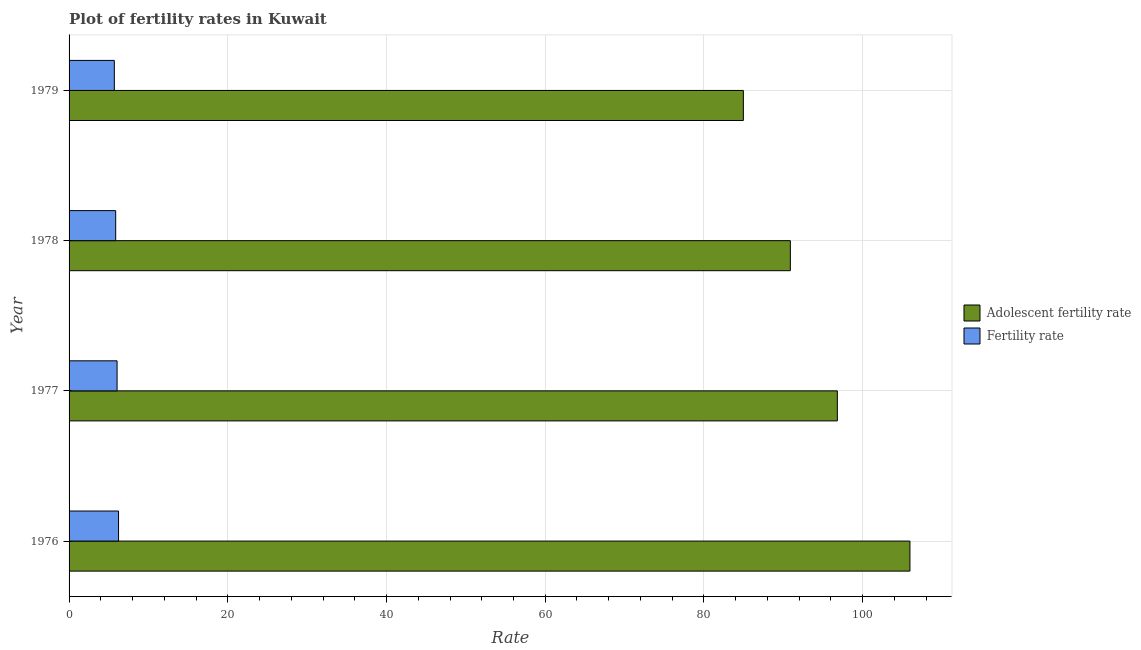How many groups of bars are there?
Make the answer very short. 4. Are the number of bars per tick equal to the number of legend labels?
Offer a very short reply. Yes. Are the number of bars on each tick of the Y-axis equal?
Offer a very short reply. Yes. How many bars are there on the 2nd tick from the bottom?
Keep it short and to the point. 2. What is the label of the 1st group of bars from the top?
Provide a succinct answer. 1979. What is the adolescent fertility rate in 1976?
Make the answer very short. 105.95. Across all years, what is the maximum fertility rate?
Your response must be concise. 6.23. Across all years, what is the minimum fertility rate?
Your response must be concise. 5.7. In which year was the fertility rate maximum?
Offer a very short reply. 1976. In which year was the adolescent fertility rate minimum?
Keep it short and to the point. 1979. What is the total adolescent fertility rate in the graph?
Keep it short and to the point. 378.61. What is the difference between the fertility rate in 1977 and that in 1978?
Offer a very short reply. 0.18. What is the difference between the fertility rate in 1976 and the adolescent fertility rate in 1978?
Offer a very short reply. -84.65. What is the average fertility rate per year?
Your answer should be very brief. 5.96. In the year 1978, what is the difference between the adolescent fertility rate and fertility rate?
Your response must be concise. 85.01. In how many years, is the adolescent fertility rate greater than 76 ?
Provide a succinct answer. 4. What is the ratio of the adolescent fertility rate in 1976 to that in 1979?
Offer a very short reply. 1.25. Is the difference between the fertility rate in 1977 and 1978 greater than the difference between the adolescent fertility rate in 1977 and 1978?
Keep it short and to the point. No. What is the difference between the highest and the second highest fertility rate?
Ensure brevity in your answer.  0.18. What is the difference between the highest and the lowest adolescent fertility rate?
Give a very brief answer. 20.99. In how many years, is the fertility rate greater than the average fertility rate taken over all years?
Your response must be concise. 2. What does the 2nd bar from the top in 1976 represents?
Provide a succinct answer. Adolescent fertility rate. What does the 1st bar from the bottom in 1976 represents?
Give a very brief answer. Adolescent fertility rate. How many bars are there?
Make the answer very short. 8. Are the values on the major ticks of X-axis written in scientific E-notation?
Your answer should be very brief. No. Does the graph contain grids?
Give a very brief answer. Yes. How many legend labels are there?
Offer a very short reply. 2. How are the legend labels stacked?
Provide a succinct answer. Vertical. What is the title of the graph?
Provide a short and direct response. Plot of fertility rates in Kuwait. Does "State government" appear as one of the legend labels in the graph?
Your answer should be very brief. No. What is the label or title of the X-axis?
Provide a succinct answer. Rate. What is the label or title of the Y-axis?
Provide a succinct answer. Year. What is the Rate of Adolescent fertility rate in 1976?
Offer a very short reply. 105.95. What is the Rate in Fertility rate in 1976?
Your answer should be compact. 6.23. What is the Rate of Adolescent fertility rate in 1977?
Provide a short and direct response. 96.81. What is the Rate in Fertility rate in 1977?
Keep it short and to the point. 6.05. What is the Rate of Adolescent fertility rate in 1978?
Offer a very short reply. 90.89. What is the Rate of Fertility rate in 1978?
Ensure brevity in your answer.  5.87. What is the Rate of Adolescent fertility rate in 1979?
Provide a succinct answer. 84.96. What is the Rate in Fertility rate in 1979?
Provide a succinct answer. 5.7. Across all years, what is the maximum Rate of Adolescent fertility rate?
Offer a very short reply. 105.95. Across all years, what is the maximum Rate in Fertility rate?
Keep it short and to the point. 6.23. Across all years, what is the minimum Rate of Adolescent fertility rate?
Your answer should be compact. 84.96. Across all years, what is the minimum Rate of Fertility rate?
Ensure brevity in your answer.  5.7. What is the total Rate in Adolescent fertility rate in the graph?
Provide a succinct answer. 378.61. What is the total Rate of Fertility rate in the graph?
Give a very brief answer. 23.86. What is the difference between the Rate in Adolescent fertility rate in 1976 and that in 1977?
Your answer should be very brief. 9.15. What is the difference between the Rate in Fertility rate in 1976 and that in 1977?
Provide a succinct answer. 0.18. What is the difference between the Rate of Adolescent fertility rate in 1976 and that in 1978?
Offer a very short reply. 15.07. What is the difference between the Rate of Fertility rate in 1976 and that in 1978?
Your answer should be very brief. 0.36. What is the difference between the Rate of Adolescent fertility rate in 1976 and that in 1979?
Provide a short and direct response. 20.99. What is the difference between the Rate in Fertility rate in 1976 and that in 1979?
Provide a succinct answer. 0.53. What is the difference between the Rate of Adolescent fertility rate in 1977 and that in 1978?
Your answer should be compact. 5.92. What is the difference between the Rate of Fertility rate in 1977 and that in 1978?
Make the answer very short. 0.18. What is the difference between the Rate of Adolescent fertility rate in 1977 and that in 1979?
Offer a very short reply. 11.84. What is the difference between the Rate of Fertility rate in 1977 and that in 1979?
Offer a terse response. 0.35. What is the difference between the Rate of Adolescent fertility rate in 1978 and that in 1979?
Make the answer very short. 5.92. What is the difference between the Rate of Fertility rate in 1978 and that in 1979?
Offer a very short reply. 0.17. What is the difference between the Rate in Adolescent fertility rate in 1976 and the Rate in Fertility rate in 1977?
Keep it short and to the point. 99.9. What is the difference between the Rate in Adolescent fertility rate in 1976 and the Rate in Fertility rate in 1978?
Offer a terse response. 100.08. What is the difference between the Rate in Adolescent fertility rate in 1976 and the Rate in Fertility rate in 1979?
Provide a short and direct response. 100.25. What is the difference between the Rate of Adolescent fertility rate in 1977 and the Rate of Fertility rate in 1978?
Keep it short and to the point. 90.93. What is the difference between the Rate of Adolescent fertility rate in 1977 and the Rate of Fertility rate in 1979?
Offer a terse response. 91.11. What is the difference between the Rate in Adolescent fertility rate in 1978 and the Rate in Fertility rate in 1979?
Your response must be concise. 85.18. What is the average Rate of Adolescent fertility rate per year?
Ensure brevity in your answer.  94.65. What is the average Rate of Fertility rate per year?
Offer a terse response. 5.97. In the year 1976, what is the difference between the Rate in Adolescent fertility rate and Rate in Fertility rate?
Ensure brevity in your answer.  99.72. In the year 1977, what is the difference between the Rate in Adolescent fertility rate and Rate in Fertility rate?
Your answer should be compact. 90.76. In the year 1978, what is the difference between the Rate of Adolescent fertility rate and Rate of Fertility rate?
Provide a succinct answer. 85.01. In the year 1979, what is the difference between the Rate of Adolescent fertility rate and Rate of Fertility rate?
Make the answer very short. 79.26. What is the ratio of the Rate in Adolescent fertility rate in 1976 to that in 1977?
Keep it short and to the point. 1.09. What is the ratio of the Rate of Fertility rate in 1976 to that in 1977?
Your answer should be very brief. 1.03. What is the ratio of the Rate in Adolescent fertility rate in 1976 to that in 1978?
Make the answer very short. 1.17. What is the ratio of the Rate in Fertility rate in 1976 to that in 1978?
Make the answer very short. 1.06. What is the ratio of the Rate of Adolescent fertility rate in 1976 to that in 1979?
Provide a short and direct response. 1.25. What is the ratio of the Rate in Fertility rate in 1976 to that in 1979?
Your answer should be very brief. 1.09. What is the ratio of the Rate of Adolescent fertility rate in 1977 to that in 1978?
Your answer should be compact. 1.07. What is the ratio of the Rate of Adolescent fertility rate in 1977 to that in 1979?
Your answer should be compact. 1.14. What is the ratio of the Rate in Fertility rate in 1977 to that in 1979?
Your answer should be very brief. 1.06. What is the ratio of the Rate of Adolescent fertility rate in 1978 to that in 1979?
Your response must be concise. 1.07. What is the ratio of the Rate of Fertility rate in 1978 to that in 1979?
Make the answer very short. 1.03. What is the difference between the highest and the second highest Rate of Adolescent fertility rate?
Your answer should be very brief. 9.15. What is the difference between the highest and the second highest Rate of Fertility rate?
Give a very brief answer. 0.18. What is the difference between the highest and the lowest Rate of Adolescent fertility rate?
Give a very brief answer. 20.99. What is the difference between the highest and the lowest Rate of Fertility rate?
Give a very brief answer. 0.53. 